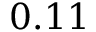<formula> <loc_0><loc_0><loc_500><loc_500>0 . 1 1</formula> 